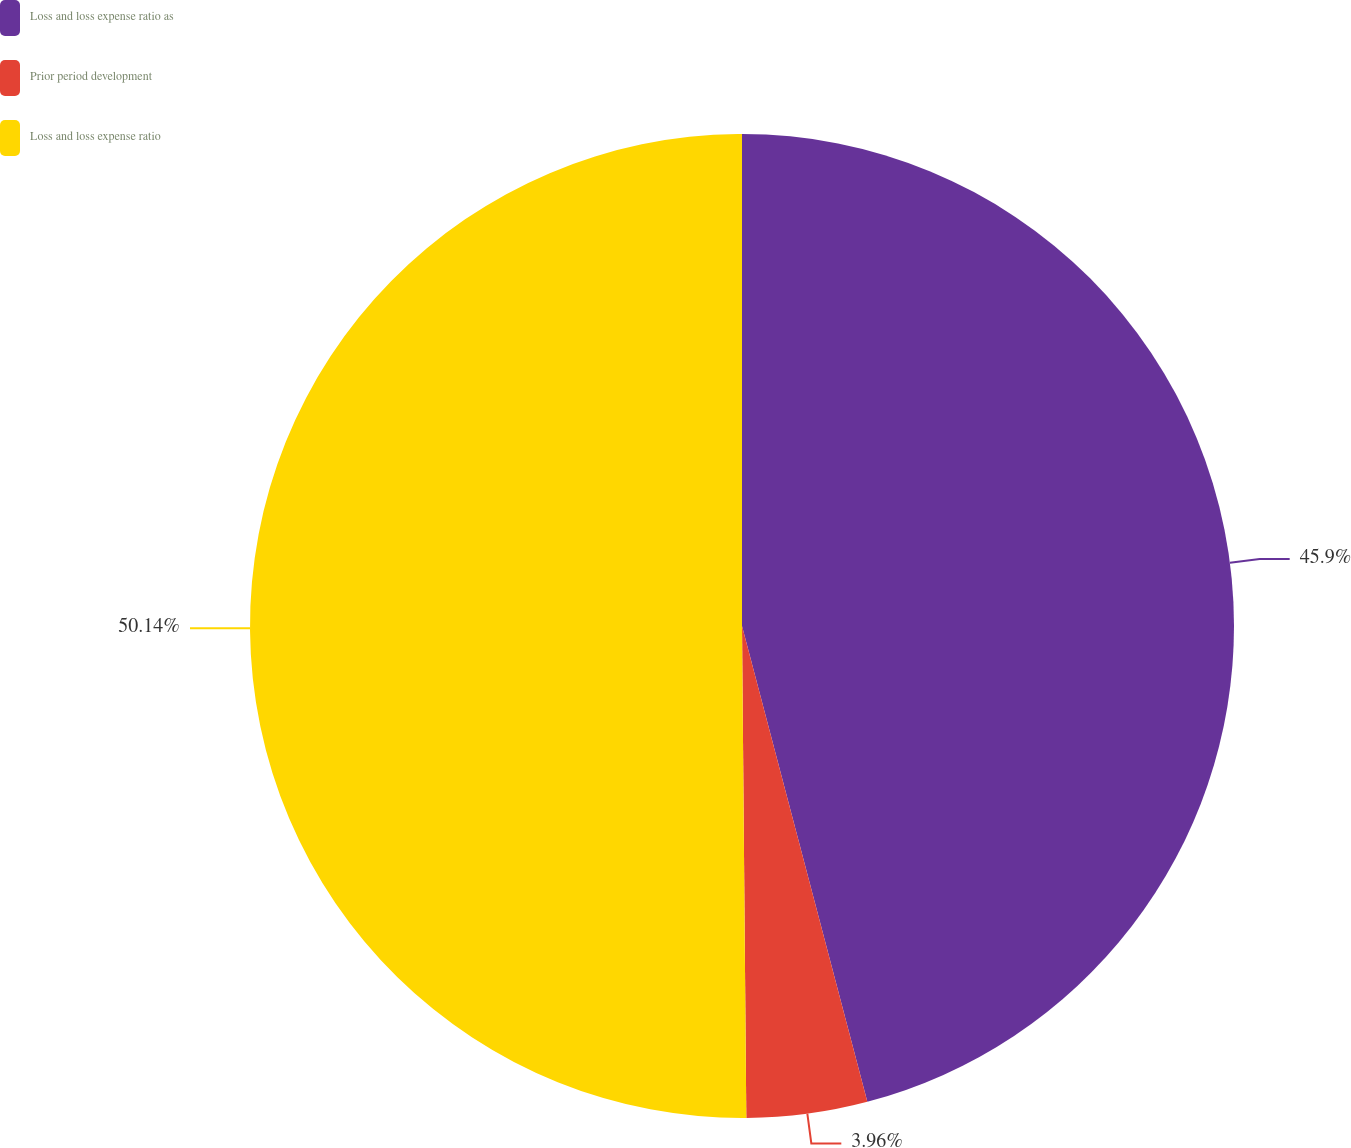Convert chart to OTSL. <chart><loc_0><loc_0><loc_500><loc_500><pie_chart><fcel>Loss and loss expense ratio as<fcel>Prior period development<fcel>Loss and loss expense ratio<nl><fcel>45.9%<fcel>3.96%<fcel>50.14%<nl></chart> 